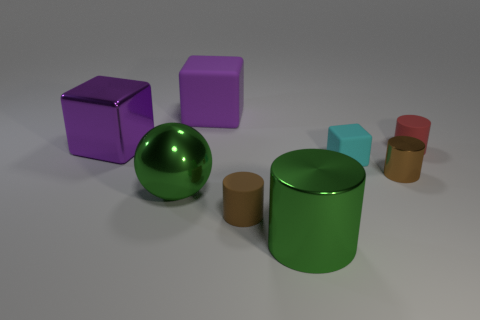There is a metal thing that is both right of the brown rubber cylinder and behind the big green cylinder; what is its shape?
Give a very brief answer. Cylinder. Is the material of the big cylinder the same as the tiny thing behind the tiny cyan rubber cube?
Ensure brevity in your answer.  No. What color is the big ball that is on the left side of the rubber cube in front of the red cylinder?
Make the answer very short. Green. There is a block that is both right of the big green metal ball and behind the cyan block; how big is it?
Provide a succinct answer. Large. What number of other things are the same shape as the small brown matte object?
Your answer should be very brief. 3. Is the shape of the purple metallic object the same as the brown thing that is behind the large ball?
Ensure brevity in your answer.  No. How many cylinders are in front of the red thing?
Your answer should be compact. 3. Are there any other things that have the same material as the large cylinder?
Your answer should be very brief. Yes. There is a green object behind the green metallic cylinder; is it the same shape as the purple metallic object?
Make the answer very short. No. The tiny rubber object that is on the right side of the small rubber block is what color?
Provide a succinct answer. Red. 